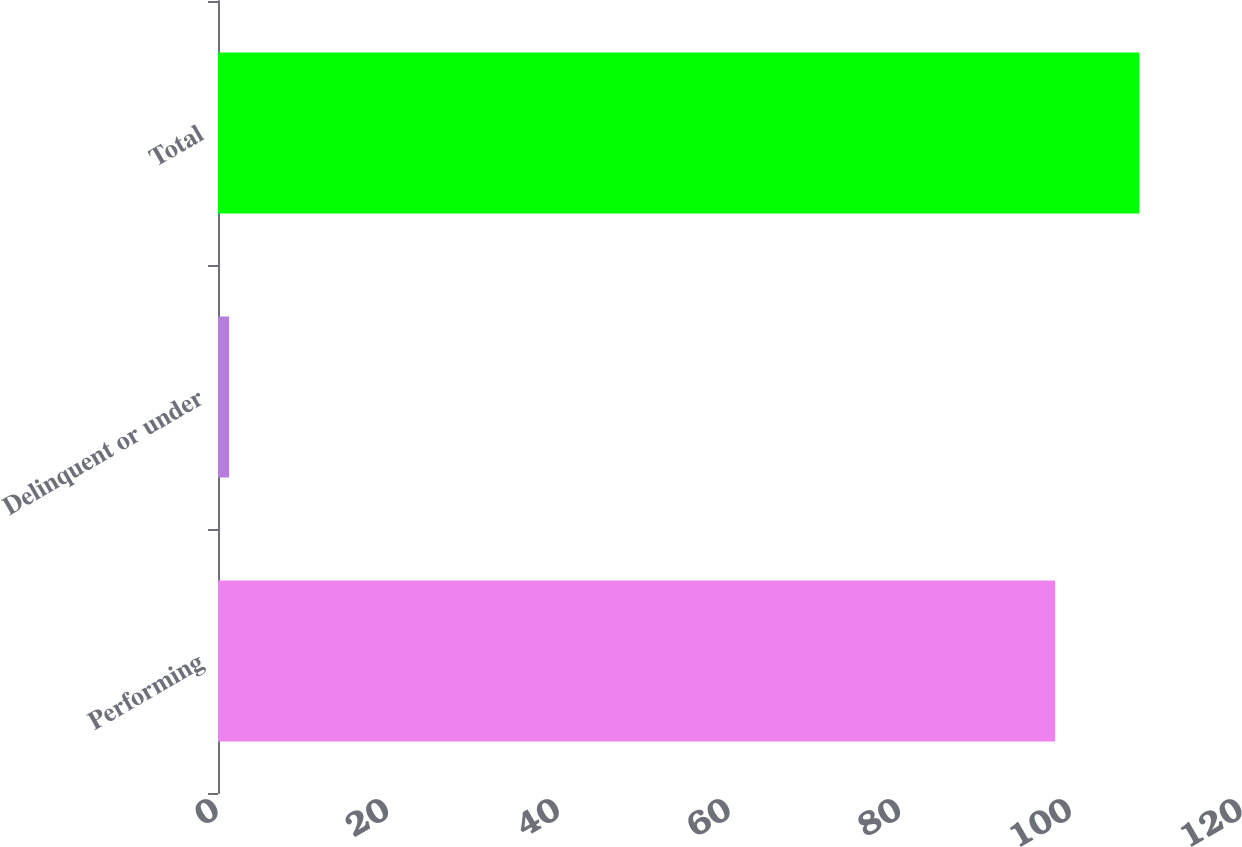Convert chart to OTSL. <chart><loc_0><loc_0><loc_500><loc_500><bar_chart><fcel>Performing<fcel>Delinquent or under<fcel>Total<nl><fcel>98.1<fcel>1.3<fcel>107.97<nl></chart> 